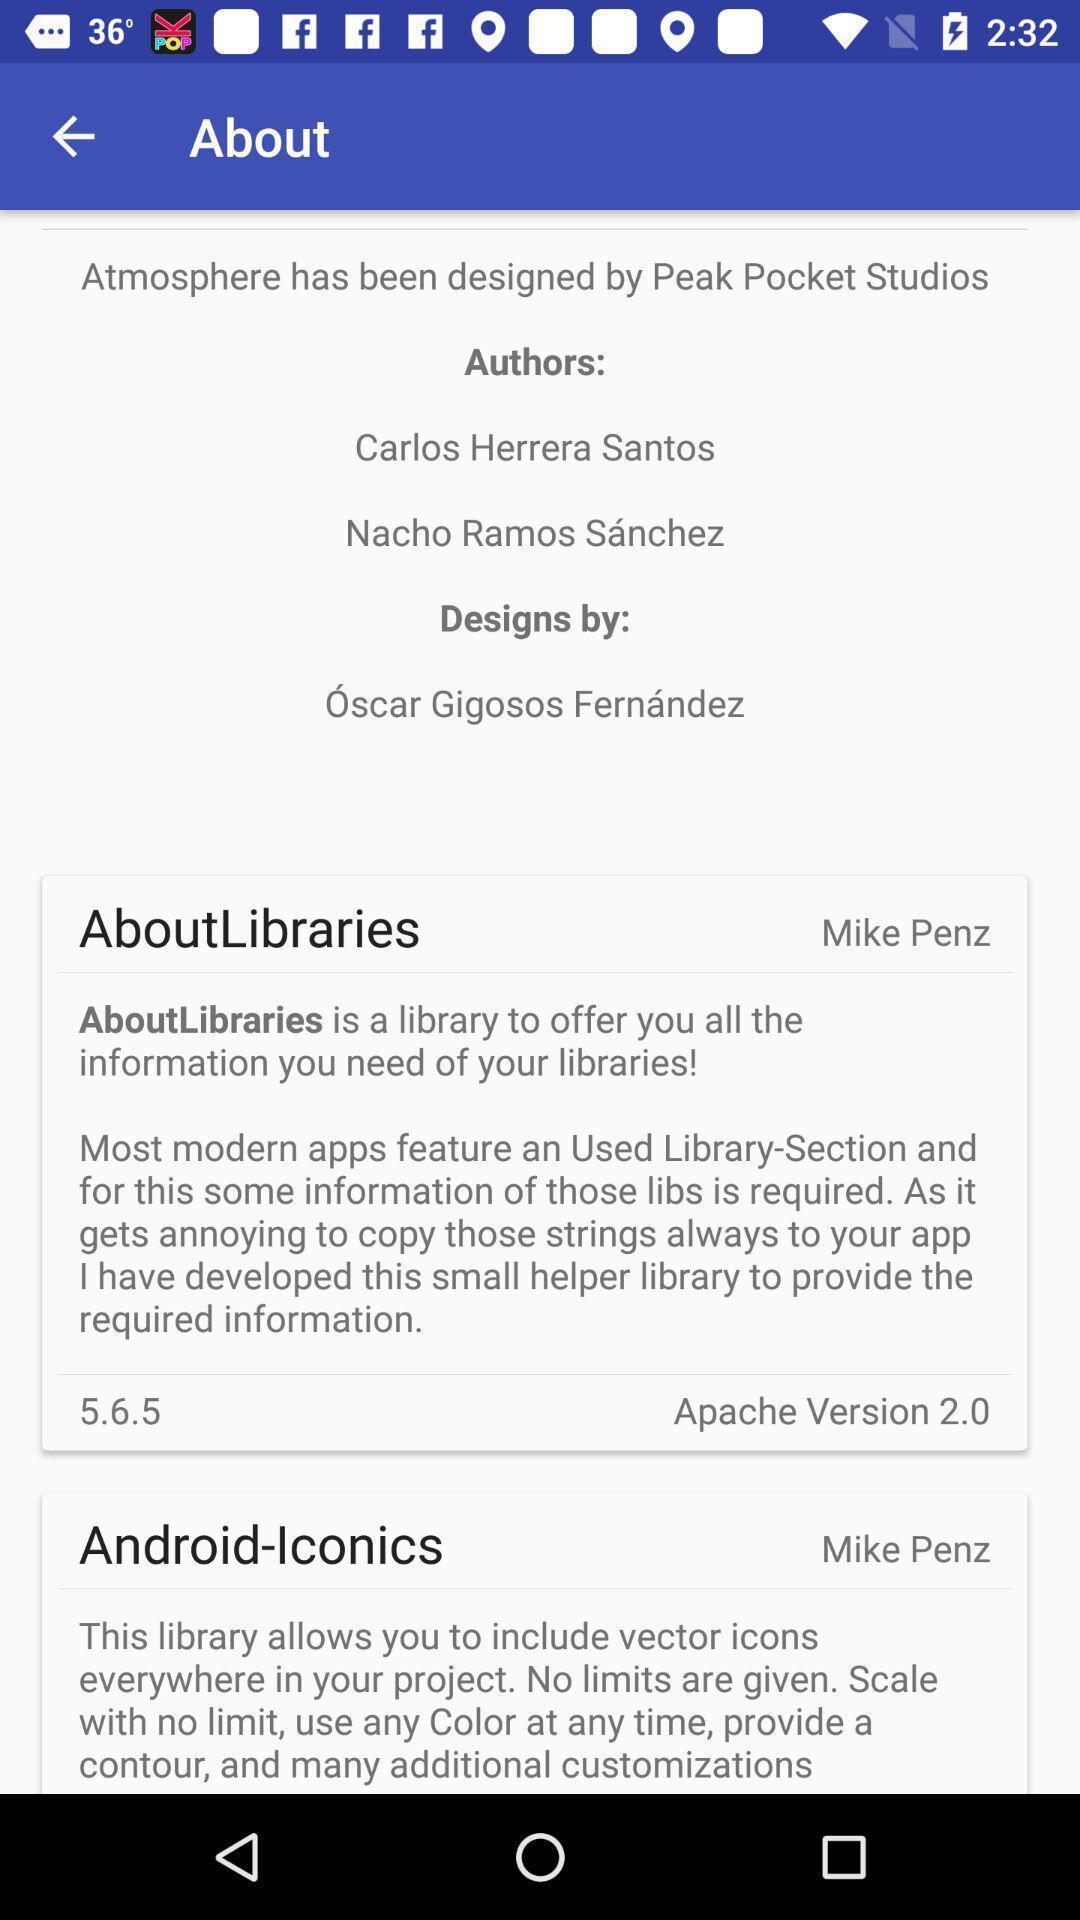Give me a summary of this screen capture. Screen shows about library information. 